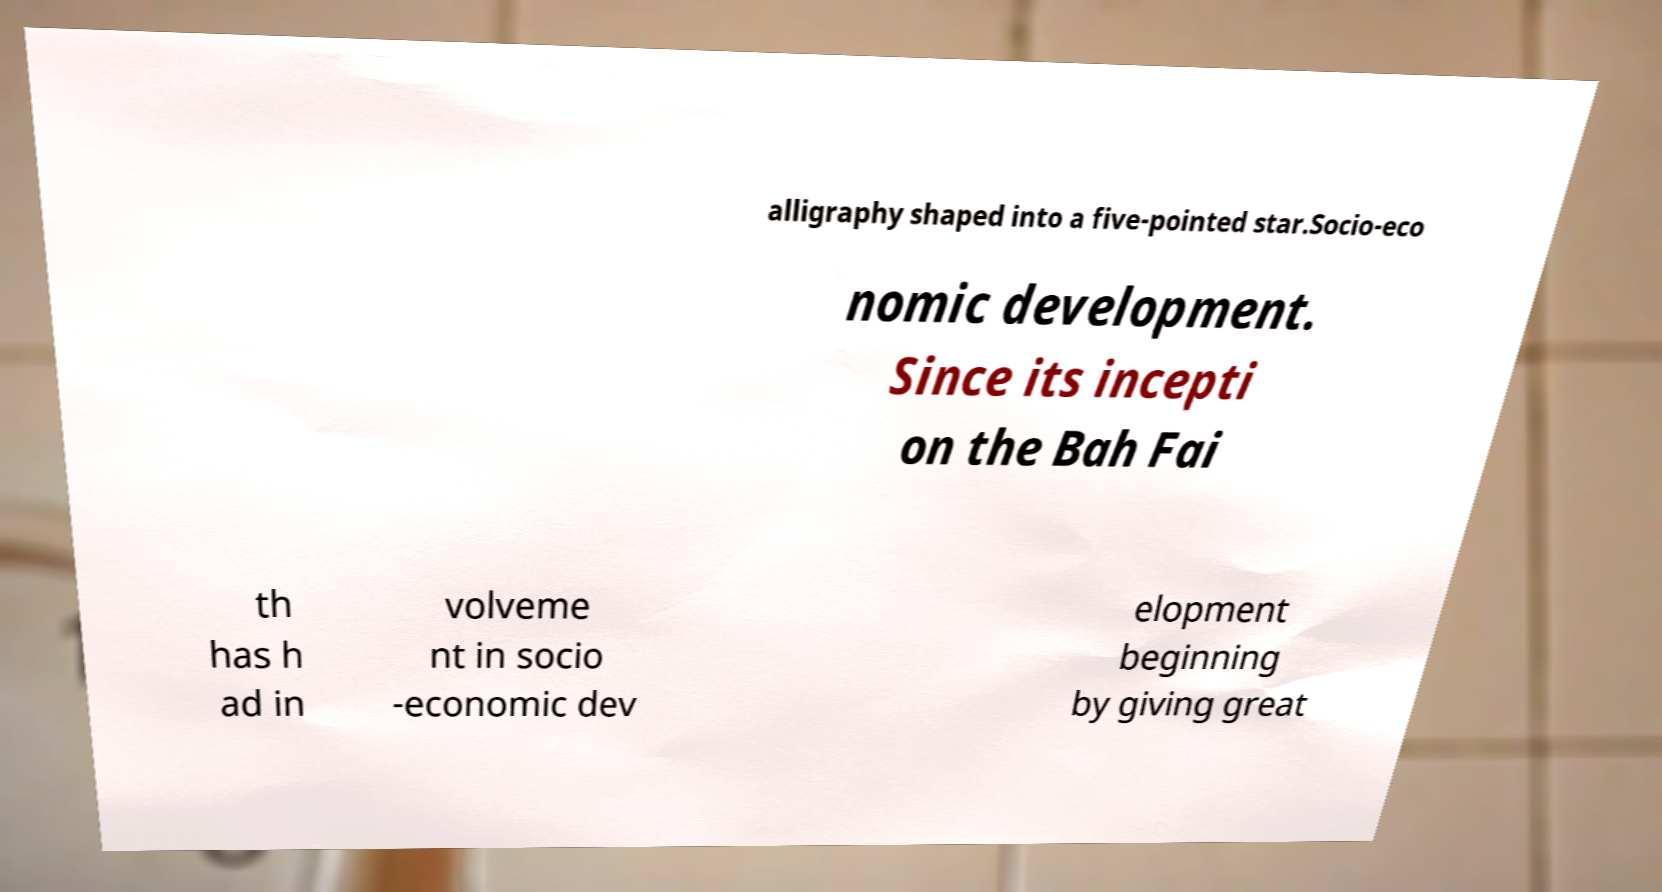There's text embedded in this image that I need extracted. Can you transcribe it verbatim? alligraphy shaped into a five-pointed star.Socio-eco nomic development. Since its incepti on the Bah Fai th has h ad in volveme nt in socio -economic dev elopment beginning by giving great 